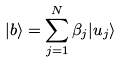<formula> <loc_0><loc_0><loc_500><loc_500>| b \rangle = \sum _ { j = 1 } ^ { N } \beta _ { j } | u _ { j } \rangle</formula> 